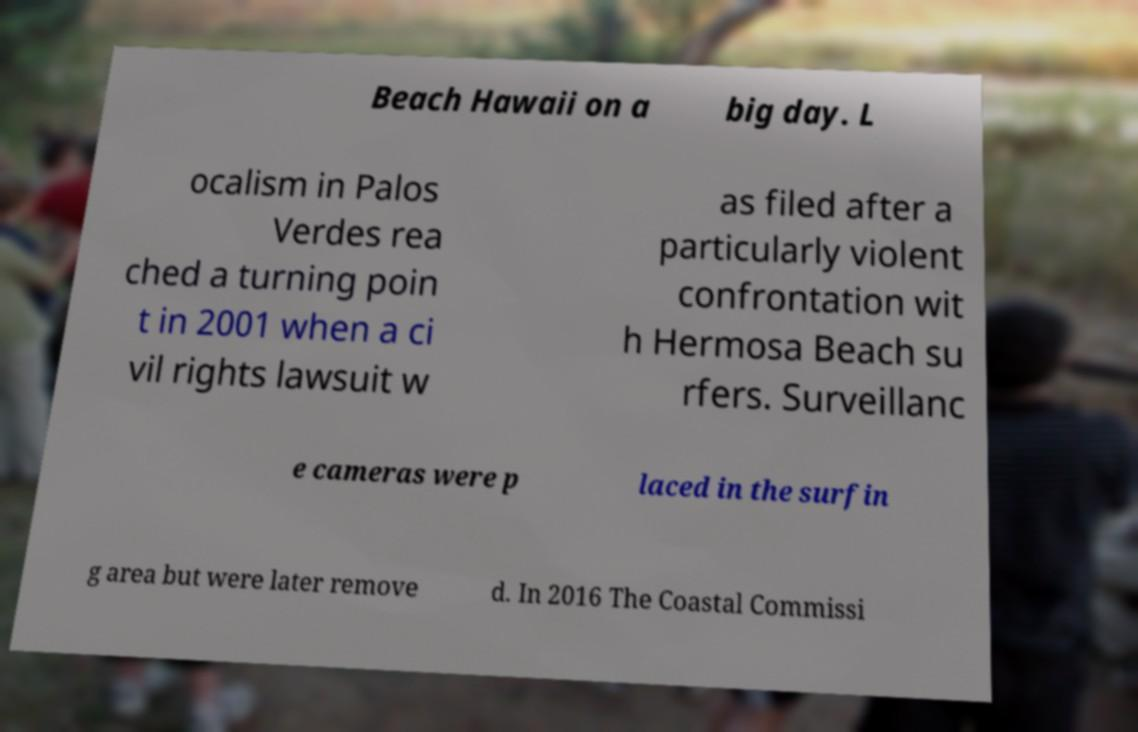I need the written content from this picture converted into text. Can you do that? Beach Hawaii on a big day. L ocalism in Palos Verdes rea ched a turning poin t in 2001 when a ci vil rights lawsuit w as filed after a particularly violent confrontation wit h Hermosa Beach su rfers. Surveillanc e cameras were p laced in the surfin g area but were later remove d. In 2016 The Coastal Commissi 